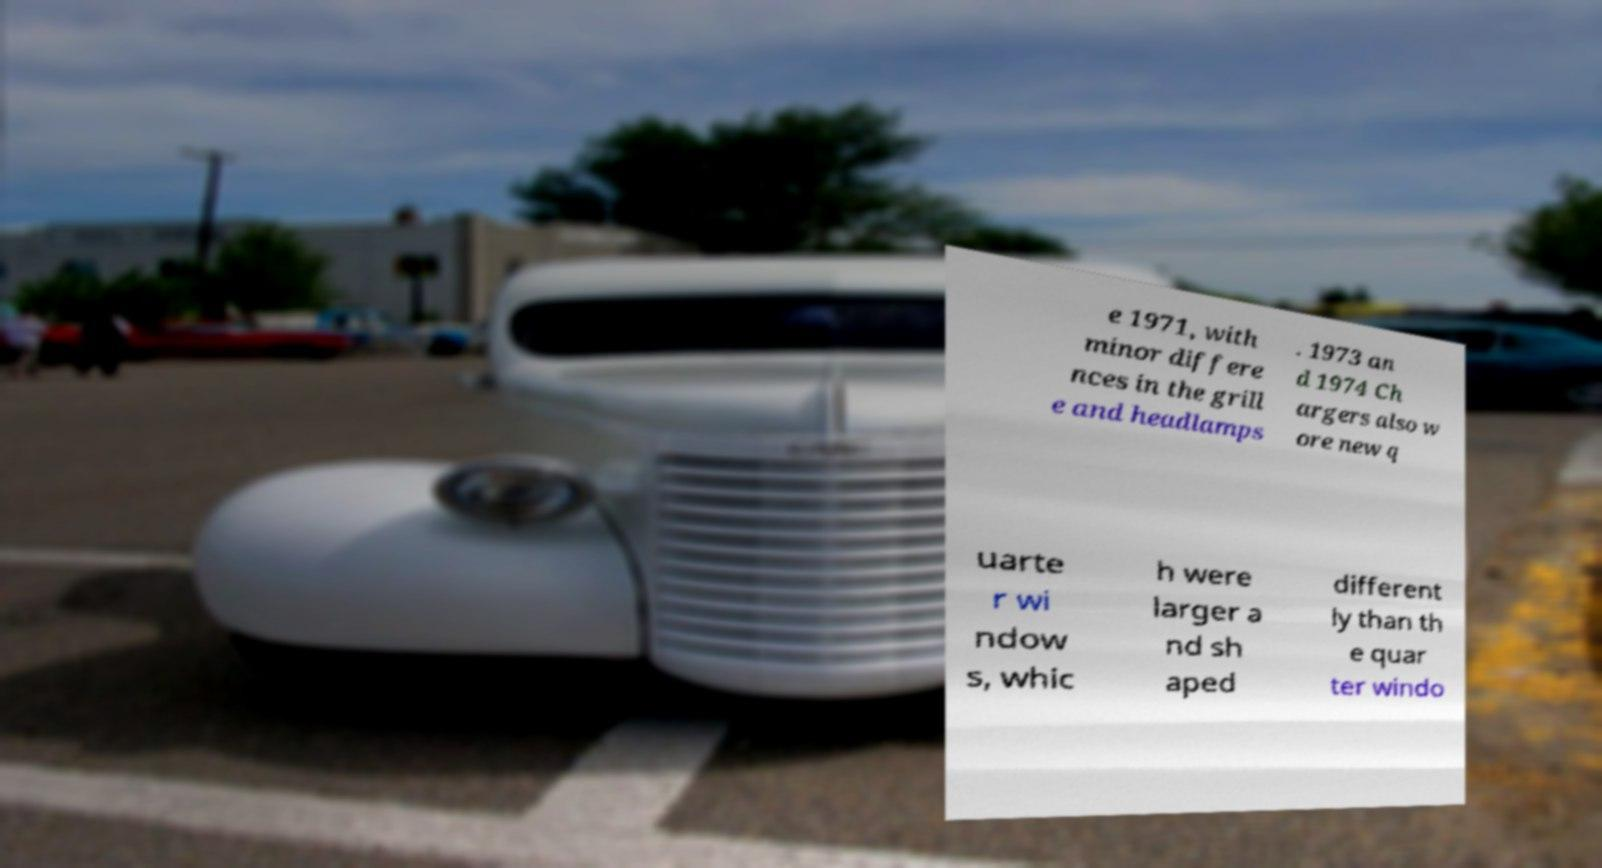There's text embedded in this image that I need extracted. Can you transcribe it verbatim? e 1971, with minor differe nces in the grill e and headlamps . 1973 an d 1974 Ch argers also w ore new q uarte r wi ndow s, whic h were larger a nd sh aped different ly than th e quar ter windo 